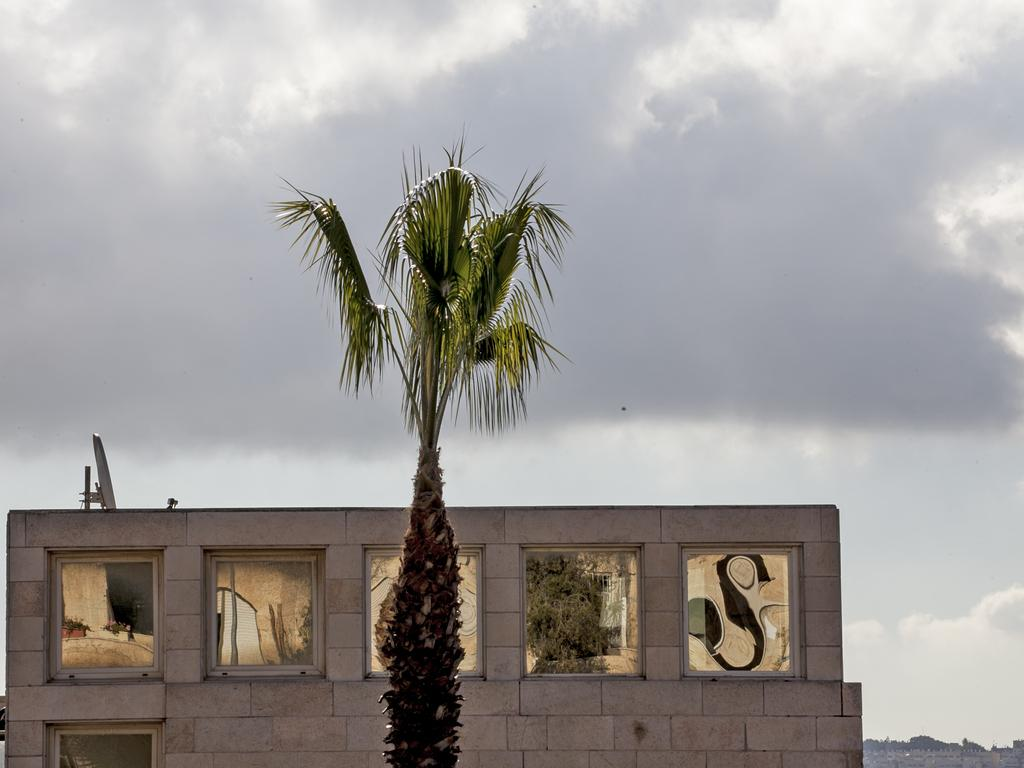What type of natural element is present in the image? There is a tree in the image. What type of man-made structure is present in the image? There is a building in the image. What can be seen in the sky in the image? There are clouds visible in the background of the image. What type of wren can be seen perched on the tree in the image? There is no wren present in the image; only a tree is visible. How many yams are visible in the image? There are no yams present in the image. 